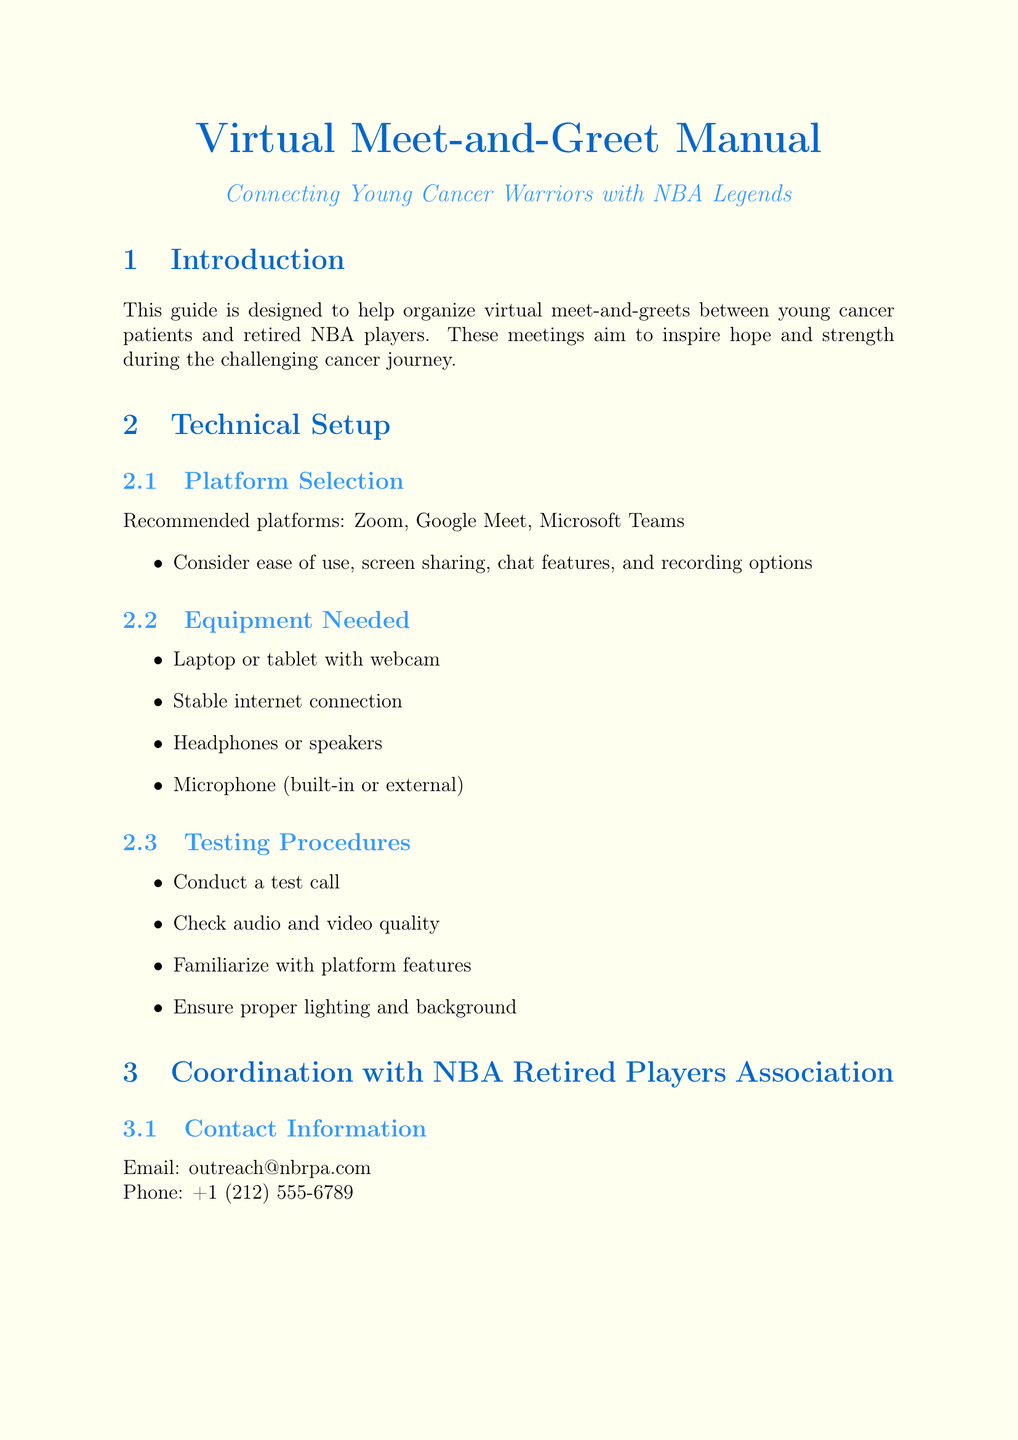What is the purpose of the manual? The manual aims to provide a comprehensive guide for organizing virtual meet-and-greets with retired NBA players, tailored for young fans battling cancer.
Answer: Comprehensive guide What platforms are recommended for the virtual meetings? The document lists Zoom, Google Meet, and Microsoft Teams as recommended platforms for the meetings.
Answer: Zoom, Google Meet, Microsoft Teams What is the email address for contacting the NBA Retired Players Association? The manual provides the email address outreach@nbrpa.com for contacting the association.
Answer: outreach@nbrpa.com How many players are listed as potential participants? The document mentions five potential retired players who could participate in the meet-and-greet.
Answer: Five What should family members do during the meet-and-greet? Family members should provide support without overshadowing the young fan.
Answer: Provide support without overshadowing What is one emotional preparation activity suggested for the young fan? The document suggests discussing expectations and excitement as one emotional preparation activity.
Answer: Discuss expectations and excitement What is a follow-up activity mentioned in the post meet-and-greet section? The manual recommends sending a thank-you note to the retired player as a follow-up activity.
Answer: Sending a thank-you note What medical consideration should be taken into account? The document advises consulting with the patient's medical team before scheduling the meeting.
Answer: Consult with the patient's medical team Which retired player is mentioned first in the list of potential participants? Magic Johnson is listed as the first potential retired player in the document.
Answer: Magic Johnson 